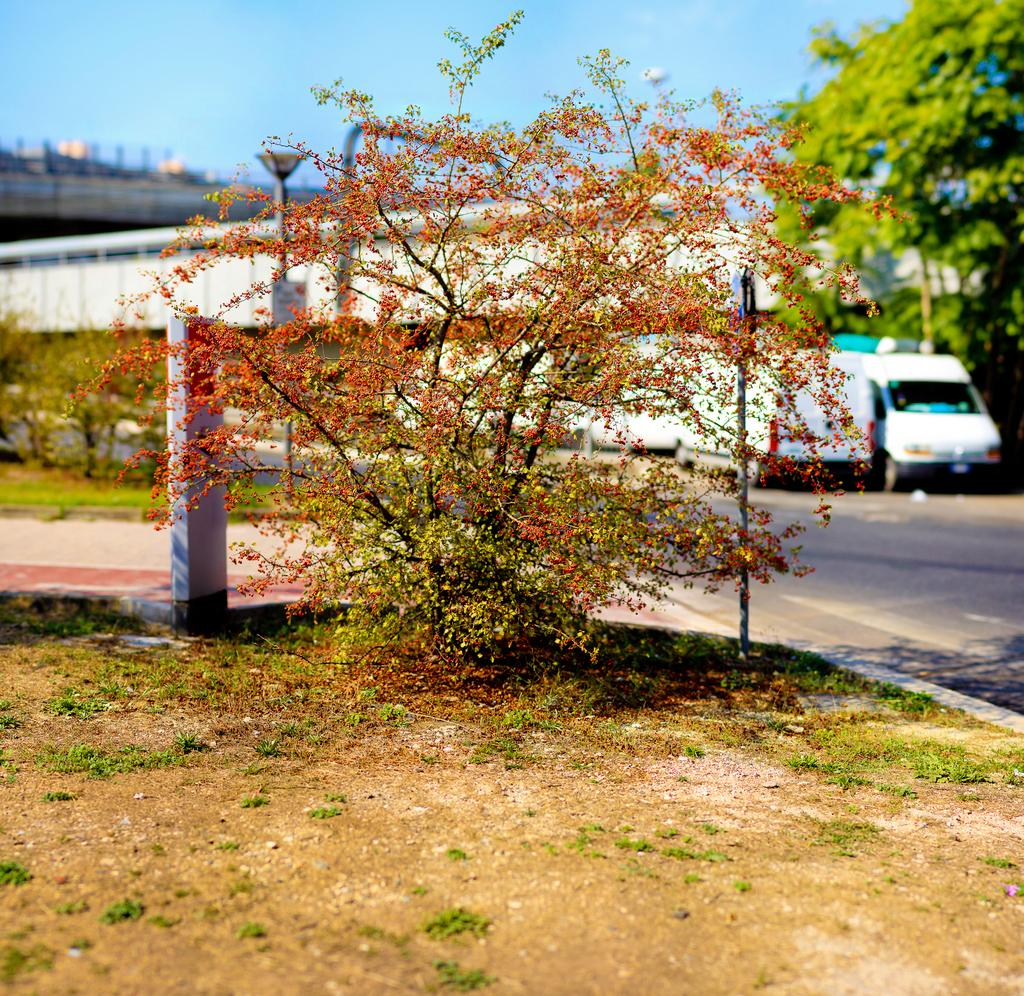What type of vegetation can be seen in the image? There is grass and a plant visible in the image. What type of man-made structure is visible in the image? There is a road and a building visible in the image. What else can be seen in the background of the image? Vehicles, trees, and a building are visible in the background of the image. What type of powder can be seen on the tramp in the image? There is no tramp or powder present in the image. 